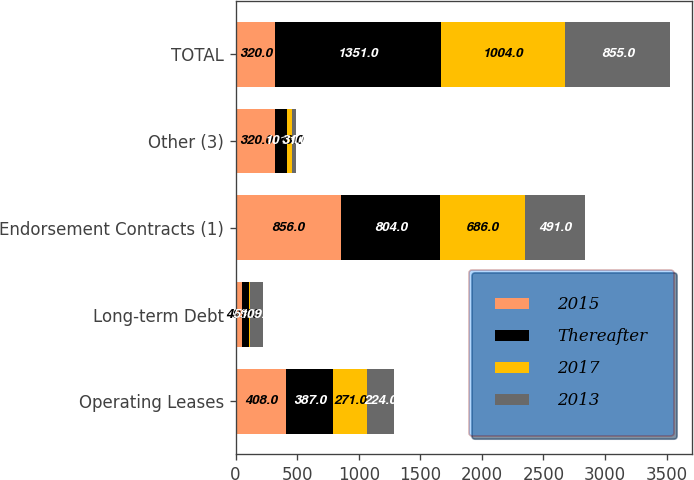<chart> <loc_0><loc_0><loc_500><loc_500><stacked_bar_chart><ecel><fcel>Operating Leases<fcel>Long-term Debt<fcel>Endorsement Contracts (1)<fcel>Other (3)<fcel>TOTAL<nl><fcel>2015<fcel>408<fcel>49<fcel>856<fcel>320<fcel>320<nl><fcel>Thereafter<fcel>387<fcel>59<fcel>804<fcel>101<fcel>1351<nl><fcel>2017<fcel>271<fcel>9<fcel>686<fcel>38<fcel>1004<nl><fcel>2013<fcel>224<fcel>109<fcel>491<fcel>31<fcel>855<nl></chart> 